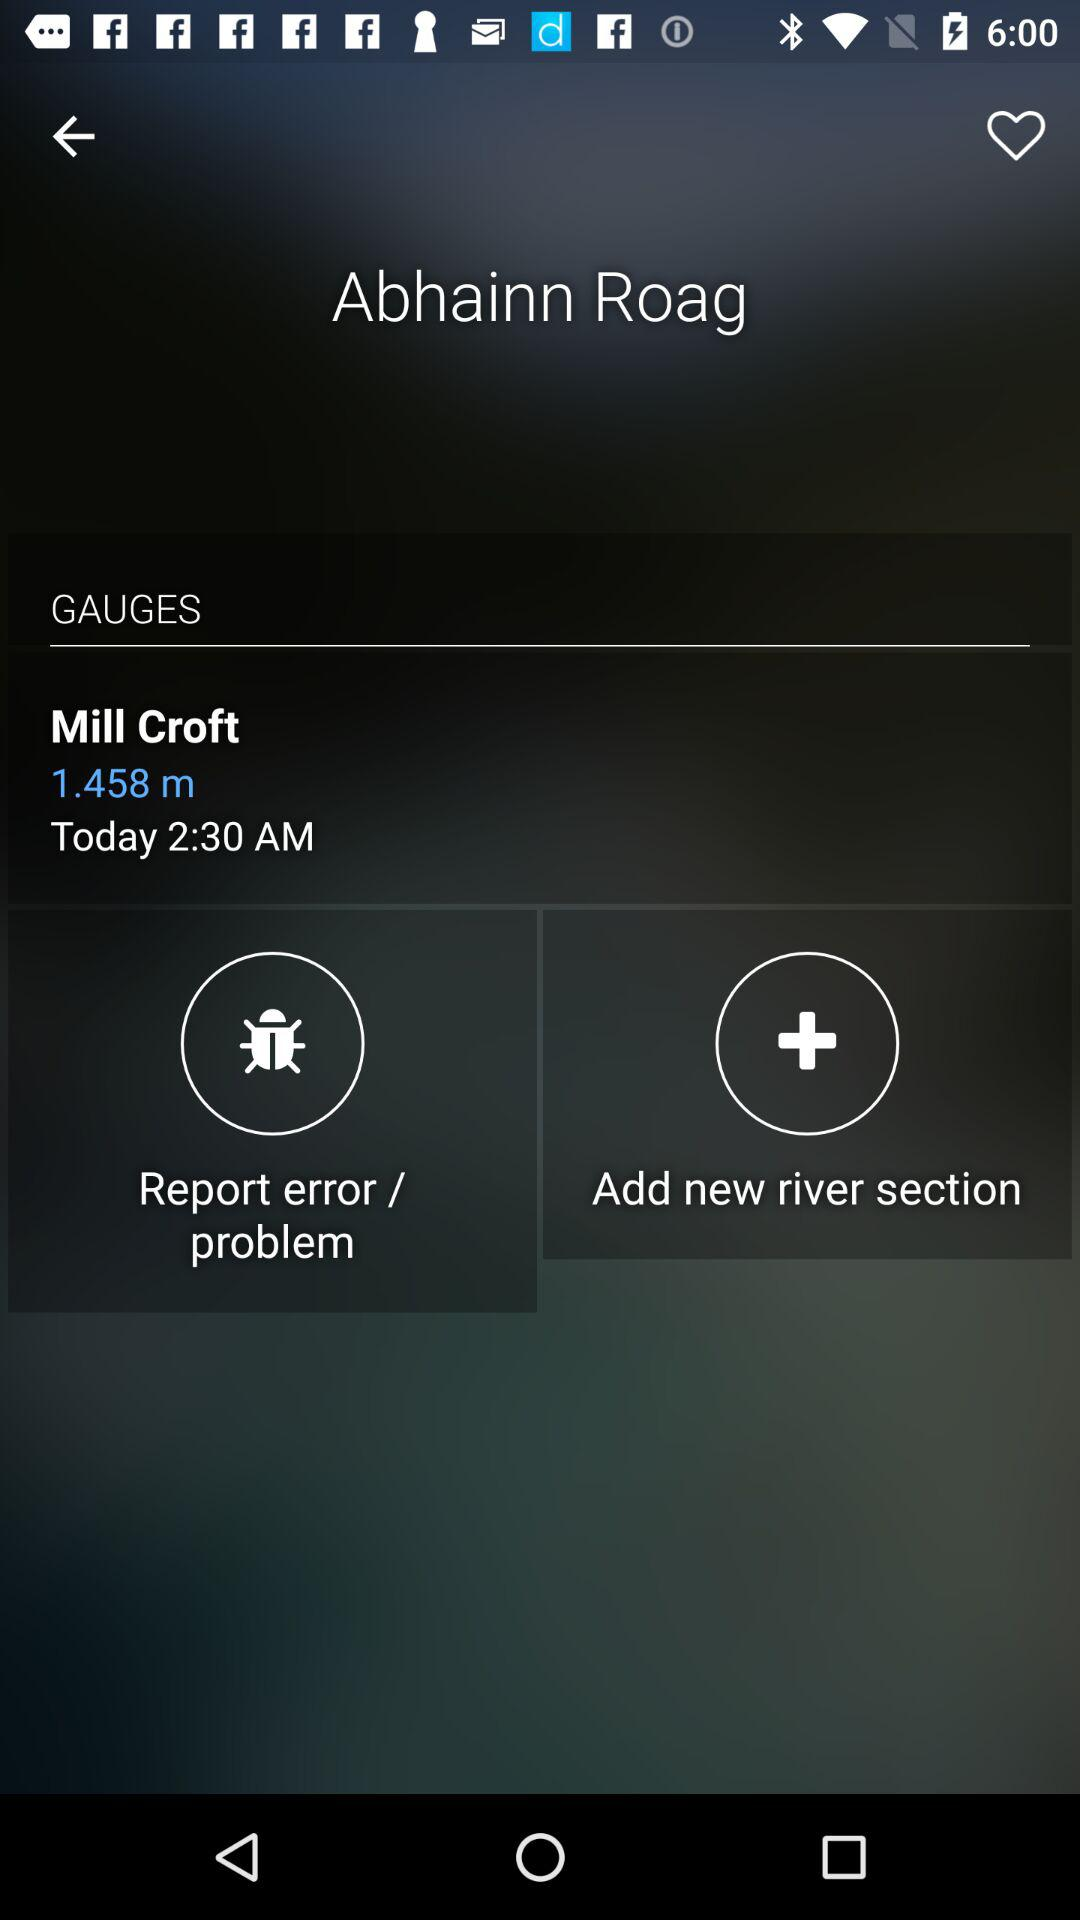How many followers are there?
When the provided information is insufficient, respond with <no answer>. <no answer> 